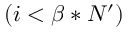Convert formula to latex. <formula><loc_0><loc_0><loc_500><loc_500>( i < \beta * N ^ { \prime } )</formula> 